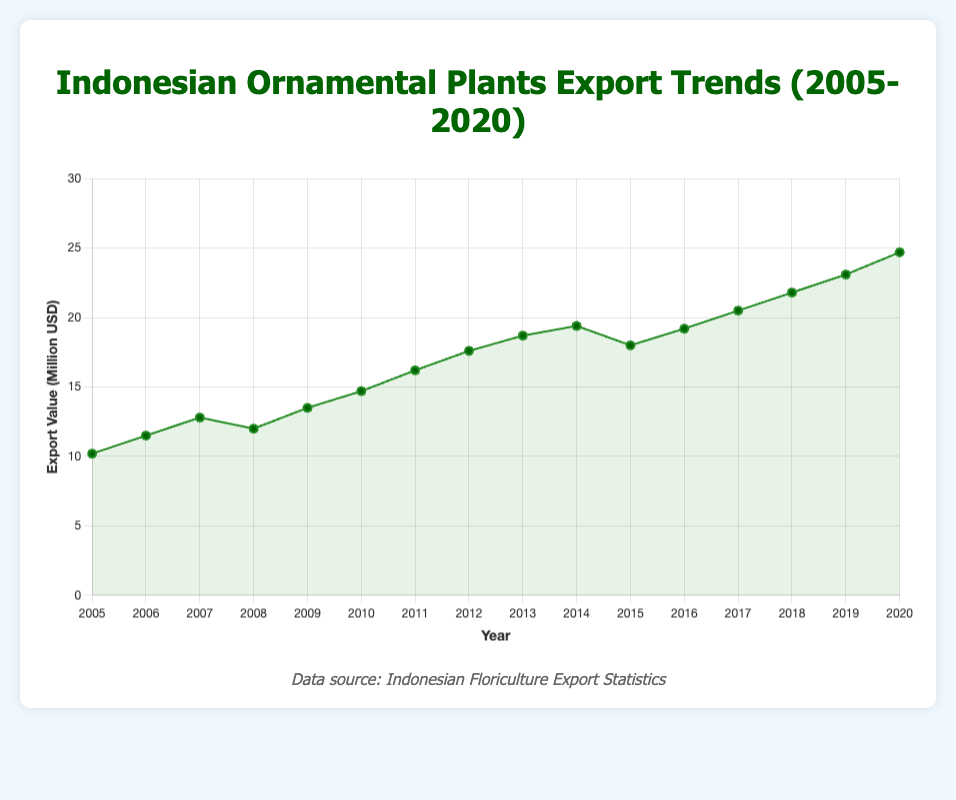What was the export value in 2010? Look at the data point for the year 2010 on the x-axis and see the corresponding value on the y-axis. It shows that the export value was $14.7 million.
Answer: $14.7 million In which year did the export value experience a decrease compared to the previous year? By examining the line chart, the export value decreased in 2008 compared to 2007 and also in 2015 compared to 2014.
Answer: 2008 and 2015 What is the total export value from 2018 to 2020? Sum the export values of the years 2018, 2019, and 2020: 21.8 million + 23.1 million + 24.7 million = 69.6 million.
Answer: 69.6 million By how much did the export value increase from 2005 to 2020? Subtract the export value in 2005 from the export value in 2020: 24.7 million - 10.2 million = 14.5 million.
Answer: 14.5 million Which year had the highest export value, and what was the value? Identify the peak point on the line chart, which shows that 2020 had the highest export value with $24.7 million.
Answer: 2020, $24.7 million What are the three consecutive years with the highest average export value? Calculate the average export value for each three-year period and compare them:
2018-2020: (21.8 + 23.1 + 24.7) / 3 = 23.2
2017-2019: (20.5 + 21.8 + 23.1) / 3 = 21.8
2016-2018: (19.2 + 20.5 + 21.8) / 3 = 20.5
The highest average is for 2018-2020.
Answer: 2018-2020, 23.2 million How much was the increase in export value from 2009 to 2010? Subtract the export value of 2009 from 2010: 14.7 million - 13.5 million = 1.2 million.
Answer: 1.2 million What is the average export value for the entire period (2005-2020)? Sum all export values from 2005 to 2020 and divide by the number of years (16): 
(10.2 + 11.5 + 12.8 + 12.0 + 13.5 + 14.7 + 16.2 + 17.6 + 18.7 + 19.4 + 18.0 + 19.2 + 20.5 + 21.8 + 23.1 + 24.7) / 16 = 17.1 million.
Answer: 17.1 million Which year saw the sharpest increase in export value compared to the previous year? Determine the difference in export value between successive years and find the maximum:
2006-2005: 11.5 - 10.2 = 1.3
2007-2006: 12.8 - 11.5 = 1.3
2008-2007: 12.0 - 12.8 = -0.8
2009-2008: 13.5 - 12.0 = 1.5
2010-2009: 14.7 - 13.5 = 1.2
2011-2010: 16.2 - 14.7 = 1.5
2012-2011: 17.6 - 16.2 = 1.4
2013-2012: 18.7 - 17.6 = 1.1
2014-2013: 19.4 - 18.7 = 0.7
2015-2014: 18.0 - 19.4 = -1.4
2016-2015: 19.2 - 18.0 = 1.2
2017-2016: 20.5 - 19.2 = 1.3
2018-2017: 21.8 - 20.5 = 1.3
2019-2018: 23.1 - 21.8 = 1.3
2020-2019: 24.7 - 23.1 = 1.6
The sharpest increase is from 2019 to 2020.
Answer: 2019 to 2020 What visual trend can be observed in the export values from 2005 to 2020? Observing the line chart, there is a general upward trend with minor fluctuations, indicating an overall increase in the export values over the years.
Answer: Upward trend 